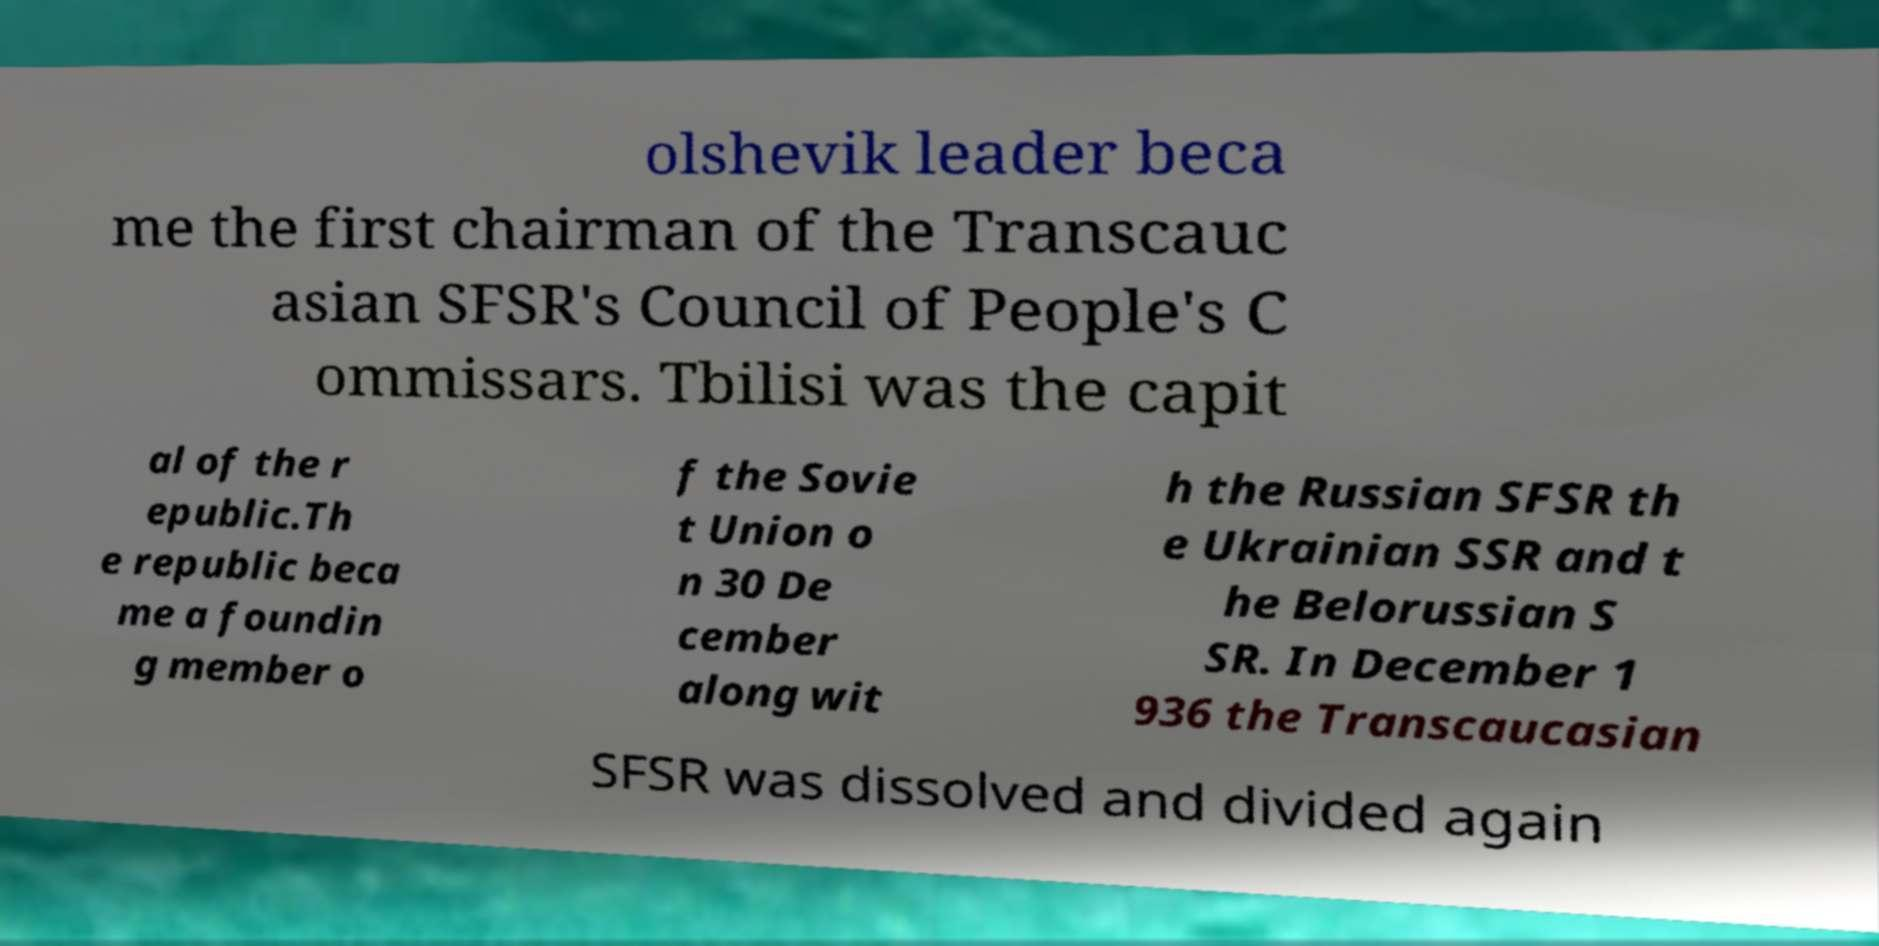Please read and relay the text visible in this image. What does it say? olshevik leader beca me the first chairman of the Transcauc asian SFSR's Council of People's C ommissars. Tbilisi was the capit al of the r epublic.Th e republic beca me a foundin g member o f the Sovie t Union o n 30 De cember along wit h the Russian SFSR th e Ukrainian SSR and t he Belorussian S SR. In December 1 936 the Transcaucasian SFSR was dissolved and divided again 